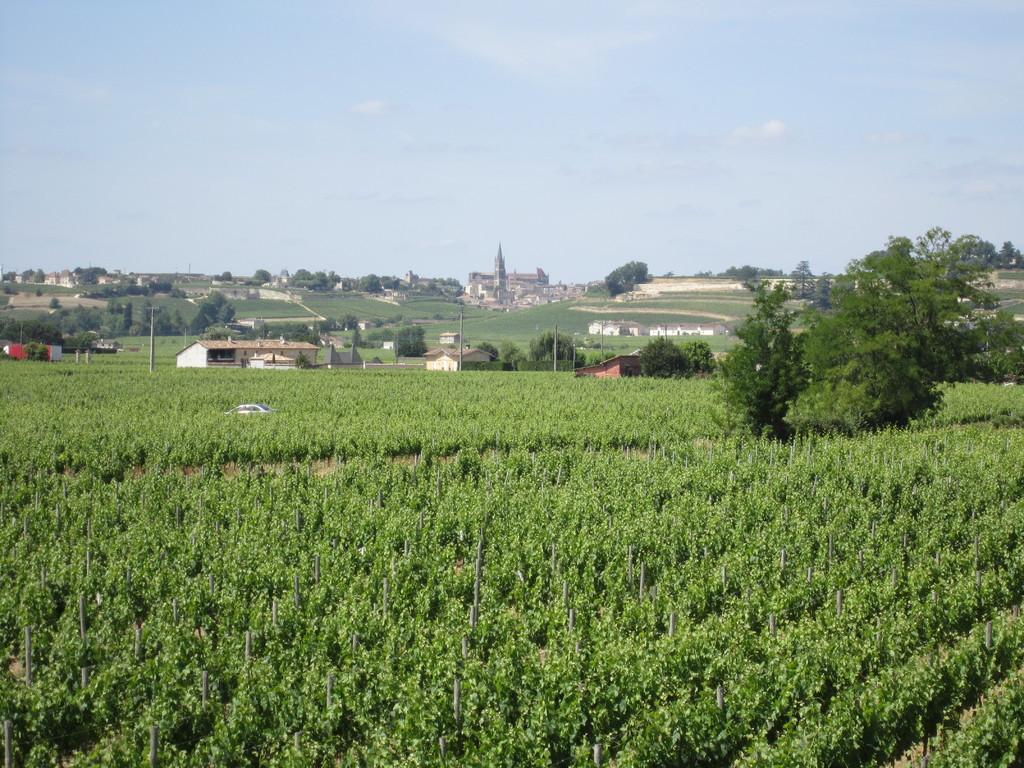What type of vegetation can be seen in the image? There are green color plants and trees in the image. What type of structures are visible in the image? There are homes visible in the image. What color is the sky in the image? The sky is blue in color. Where is the rake being used in the image? There is no rake present in the image. What level of comfort can be experienced by the plants in the image? Plants do not experience comfort, as they are not sentient beings. 